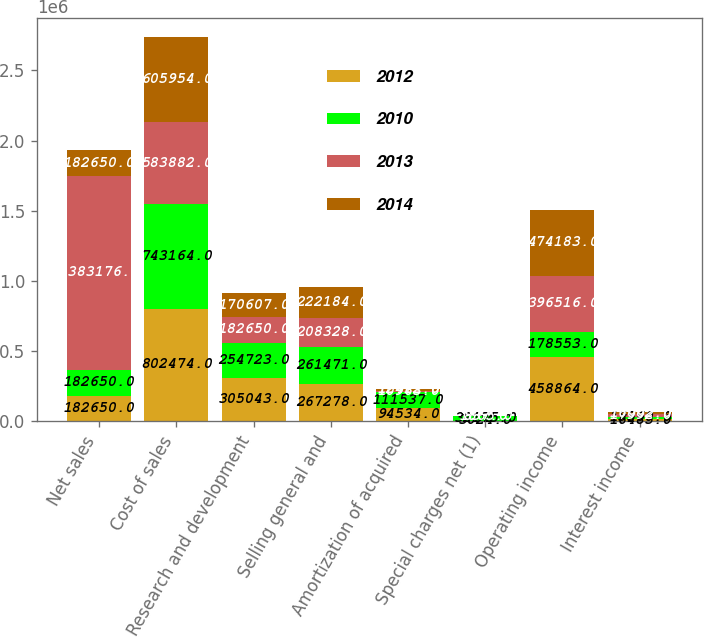Convert chart to OTSL. <chart><loc_0><loc_0><loc_500><loc_500><stacked_bar_chart><ecel><fcel>Net sales<fcel>Cost of sales<fcel>Research and development<fcel>Selling general and<fcel>Amortization of acquired<fcel>Special charges net (1)<fcel>Operating income<fcel>Interest income<nl><fcel>2012<fcel>182650<fcel>802474<fcel>305043<fcel>267278<fcel>94534<fcel>3024<fcel>458864<fcel>16485<nl><fcel>2010<fcel>182650<fcel>743164<fcel>254723<fcel>261471<fcel>111537<fcel>32175<fcel>178553<fcel>15560<nl><fcel>2013<fcel>1.38318e+06<fcel>583882<fcel>182650<fcel>208328<fcel>10963<fcel>837<fcel>396516<fcel>17992<nl><fcel>2014<fcel>182650<fcel>605954<fcel>170607<fcel>222184<fcel>12412<fcel>1865<fcel>474183<fcel>16002<nl></chart> 